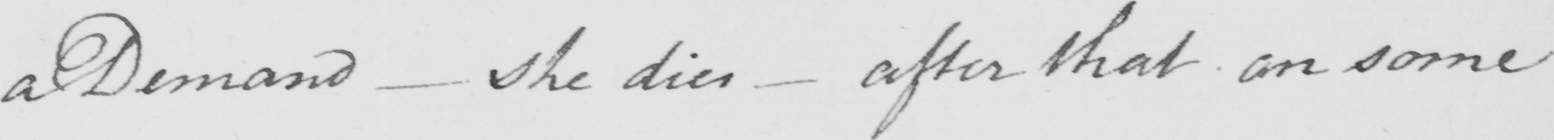Can you read and transcribe this handwriting? a Demand  _  she dies  _  after that on some 